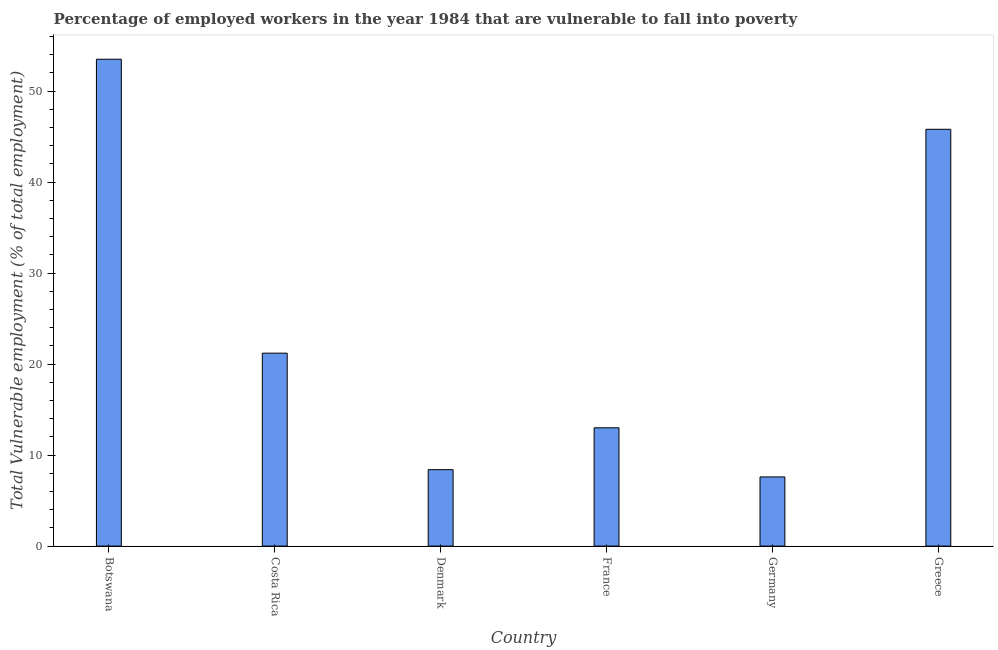Does the graph contain any zero values?
Ensure brevity in your answer.  No. Does the graph contain grids?
Make the answer very short. No. What is the title of the graph?
Give a very brief answer. Percentage of employed workers in the year 1984 that are vulnerable to fall into poverty. What is the label or title of the X-axis?
Your response must be concise. Country. What is the label or title of the Y-axis?
Your answer should be very brief. Total Vulnerable employment (% of total employment). What is the total vulnerable employment in Greece?
Offer a very short reply. 45.8. Across all countries, what is the maximum total vulnerable employment?
Ensure brevity in your answer.  53.5. Across all countries, what is the minimum total vulnerable employment?
Ensure brevity in your answer.  7.6. In which country was the total vulnerable employment maximum?
Your response must be concise. Botswana. What is the sum of the total vulnerable employment?
Offer a very short reply. 149.5. What is the difference between the total vulnerable employment in Botswana and France?
Offer a terse response. 40.5. What is the average total vulnerable employment per country?
Your answer should be compact. 24.92. What is the median total vulnerable employment?
Offer a very short reply. 17.1. What is the ratio of the total vulnerable employment in Botswana to that in France?
Provide a short and direct response. 4.12. Is the total vulnerable employment in Botswana less than that in Denmark?
Keep it short and to the point. No. Is the difference between the total vulnerable employment in Botswana and Greece greater than the difference between any two countries?
Your response must be concise. No. What is the difference between the highest and the lowest total vulnerable employment?
Make the answer very short. 45.9. How many bars are there?
Offer a terse response. 6. What is the difference between two consecutive major ticks on the Y-axis?
Your answer should be compact. 10. Are the values on the major ticks of Y-axis written in scientific E-notation?
Provide a short and direct response. No. What is the Total Vulnerable employment (% of total employment) of Botswana?
Provide a succinct answer. 53.5. What is the Total Vulnerable employment (% of total employment) of Costa Rica?
Provide a succinct answer. 21.2. What is the Total Vulnerable employment (% of total employment) of Denmark?
Keep it short and to the point. 8.4. What is the Total Vulnerable employment (% of total employment) in France?
Your answer should be very brief. 13. What is the Total Vulnerable employment (% of total employment) of Germany?
Your answer should be compact. 7.6. What is the Total Vulnerable employment (% of total employment) in Greece?
Provide a succinct answer. 45.8. What is the difference between the Total Vulnerable employment (% of total employment) in Botswana and Costa Rica?
Provide a short and direct response. 32.3. What is the difference between the Total Vulnerable employment (% of total employment) in Botswana and Denmark?
Give a very brief answer. 45.1. What is the difference between the Total Vulnerable employment (% of total employment) in Botswana and France?
Provide a short and direct response. 40.5. What is the difference between the Total Vulnerable employment (% of total employment) in Botswana and Germany?
Your response must be concise. 45.9. What is the difference between the Total Vulnerable employment (% of total employment) in Botswana and Greece?
Offer a very short reply. 7.7. What is the difference between the Total Vulnerable employment (% of total employment) in Costa Rica and Denmark?
Provide a succinct answer. 12.8. What is the difference between the Total Vulnerable employment (% of total employment) in Costa Rica and France?
Your response must be concise. 8.2. What is the difference between the Total Vulnerable employment (% of total employment) in Costa Rica and Germany?
Provide a short and direct response. 13.6. What is the difference between the Total Vulnerable employment (% of total employment) in Costa Rica and Greece?
Make the answer very short. -24.6. What is the difference between the Total Vulnerable employment (% of total employment) in Denmark and France?
Offer a terse response. -4.6. What is the difference between the Total Vulnerable employment (% of total employment) in Denmark and Germany?
Make the answer very short. 0.8. What is the difference between the Total Vulnerable employment (% of total employment) in Denmark and Greece?
Keep it short and to the point. -37.4. What is the difference between the Total Vulnerable employment (% of total employment) in France and Germany?
Provide a short and direct response. 5.4. What is the difference between the Total Vulnerable employment (% of total employment) in France and Greece?
Provide a short and direct response. -32.8. What is the difference between the Total Vulnerable employment (% of total employment) in Germany and Greece?
Your response must be concise. -38.2. What is the ratio of the Total Vulnerable employment (% of total employment) in Botswana to that in Costa Rica?
Offer a very short reply. 2.52. What is the ratio of the Total Vulnerable employment (% of total employment) in Botswana to that in Denmark?
Keep it short and to the point. 6.37. What is the ratio of the Total Vulnerable employment (% of total employment) in Botswana to that in France?
Offer a terse response. 4.12. What is the ratio of the Total Vulnerable employment (% of total employment) in Botswana to that in Germany?
Your answer should be very brief. 7.04. What is the ratio of the Total Vulnerable employment (% of total employment) in Botswana to that in Greece?
Provide a short and direct response. 1.17. What is the ratio of the Total Vulnerable employment (% of total employment) in Costa Rica to that in Denmark?
Give a very brief answer. 2.52. What is the ratio of the Total Vulnerable employment (% of total employment) in Costa Rica to that in France?
Offer a terse response. 1.63. What is the ratio of the Total Vulnerable employment (% of total employment) in Costa Rica to that in Germany?
Your answer should be compact. 2.79. What is the ratio of the Total Vulnerable employment (% of total employment) in Costa Rica to that in Greece?
Offer a very short reply. 0.46. What is the ratio of the Total Vulnerable employment (% of total employment) in Denmark to that in France?
Provide a succinct answer. 0.65. What is the ratio of the Total Vulnerable employment (% of total employment) in Denmark to that in Germany?
Offer a terse response. 1.1. What is the ratio of the Total Vulnerable employment (% of total employment) in Denmark to that in Greece?
Provide a succinct answer. 0.18. What is the ratio of the Total Vulnerable employment (% of total employment) in France to that in Germany?
Your response must be concise. 1.71. What is the ratio of the Total Vulnerable employment (% of total employment) in France to that in Greece?
Keep it short and to the point. 0.28. What is the ratio of the Total Vulnerable employment (% of total employment) in Germany to that in Greece?
Offer a terse response. 0.17. 